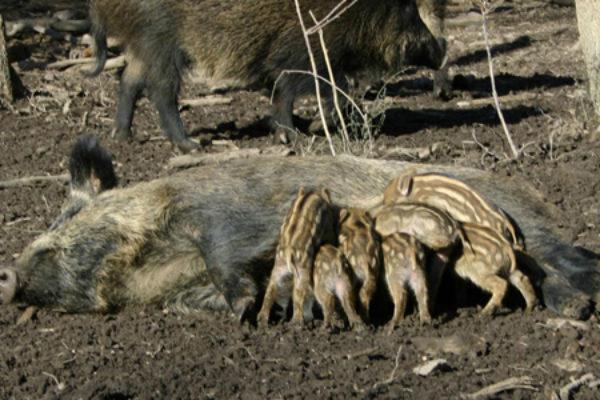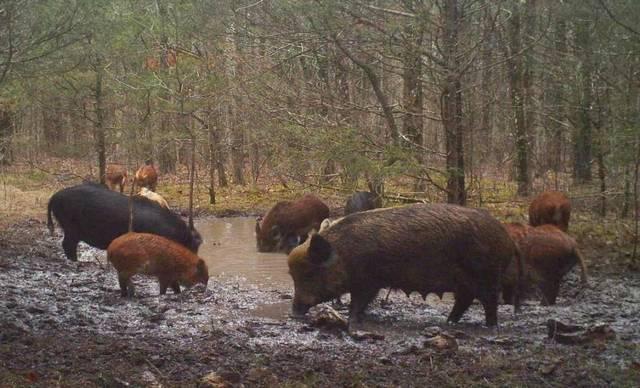The first image is the image on the left, the second image is the image on the right. For the images shown, is this caption "There is black mother boar laying the dirt with at least six nursing piglets at her belly." true? Answer yes or no. Yes. 